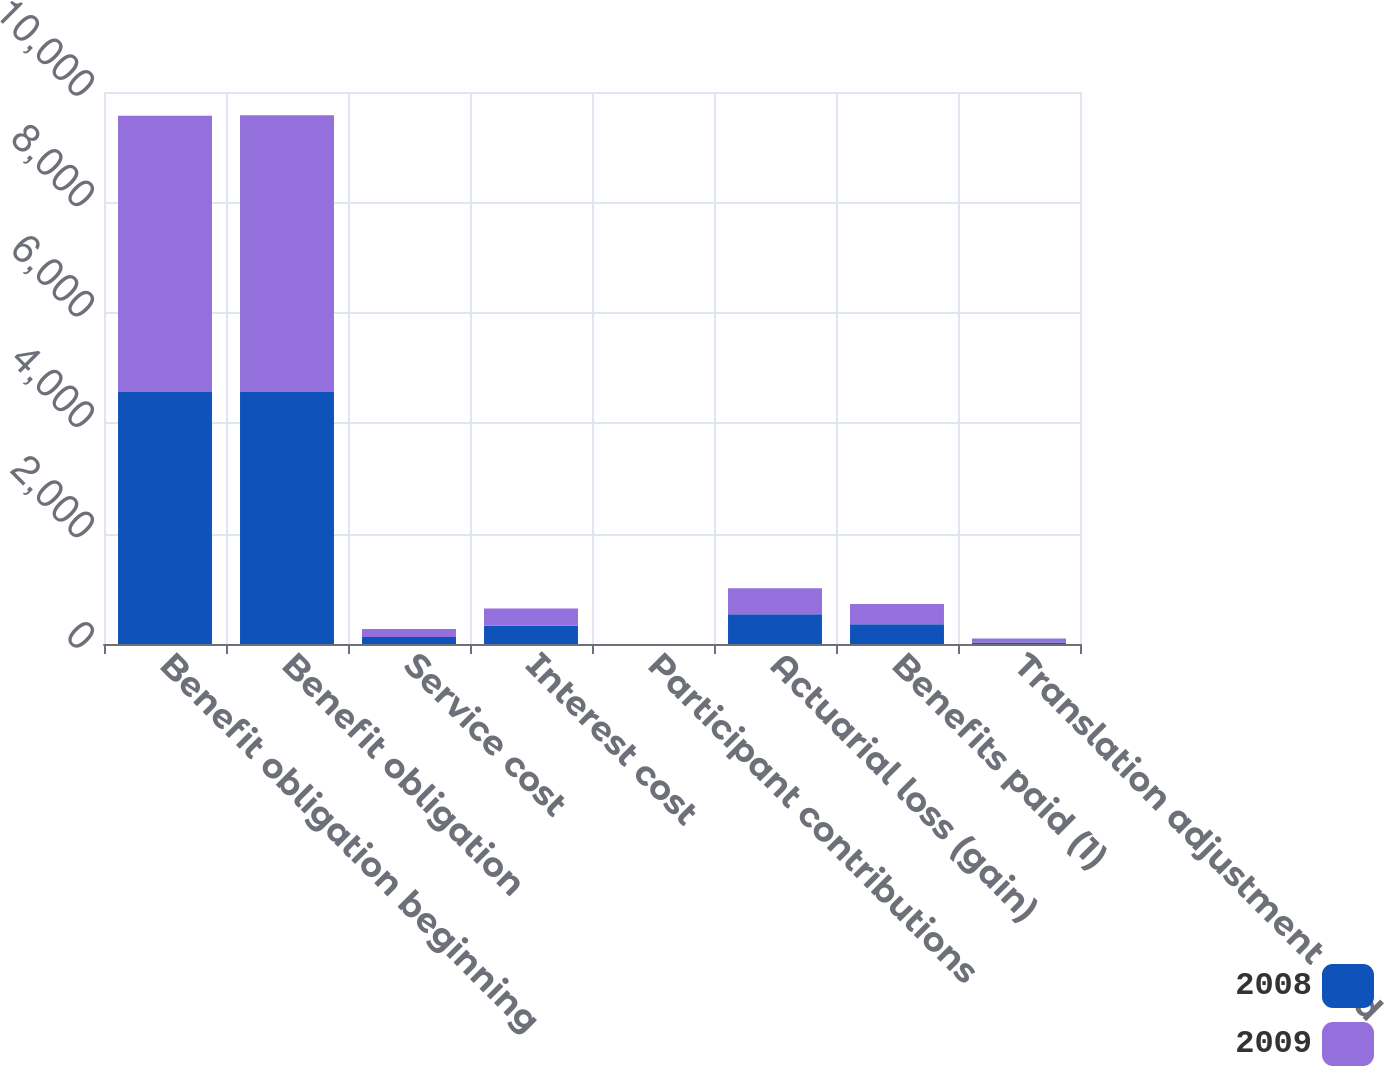Convert chart to OTSL. <chart><loc_0><loc_0><loc_500><loc_500><stacked_bar_chart><ecel><fcel>Benefit obligation beginning<fcel>Benefit obligation<fcel>Service cost<fcel>Interest cost<fcel>Participant contributions<fcel>Actuarial loss (gain)<fcel>Benefits paid (1)<fcel>Translation adjustment and<nl><fcel>2008<fcel>4566<fcel>4566<fcel>125<fcel>331<fcel>1<fcel>537<fcel>356<fcel>29<nl><fcel>2009<fcel>5002<fcel>5015<fcel>145<fcel>313<fcel>1<fcel>471<fcel>367<fcel>70<nl></chart> 